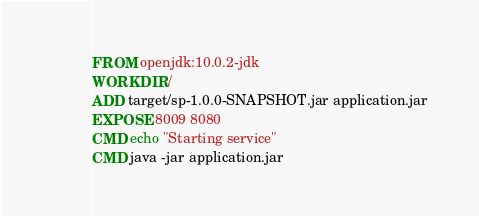<code> <loc_0><loc_0><loc_500><loc_500><_Dockerfile_>FROM openjdk:10.0.2-jdk
WORKDIR /
ADD target/sp-1.0.0-SNAPSHOT.jar application.jar
EXPOSE 8009 8080
CMD echo "Starting service"
CMD java -jar application.jar</code> 